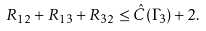<formula> <loc_0><loc_0><loc_500><loc_500>R _ { 1 2 } + R _ { 1 3 } + R _ { 3 2 } \leq \hat { C } ( \Gamma _ { 3 } ) + 2 .</formula> 